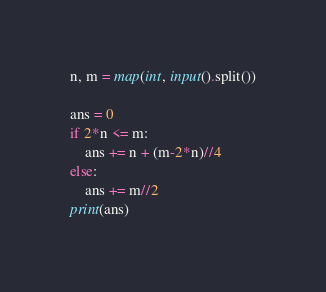Convert code to text. <code><loc_0><loc_0><loc_500><loc_500><_Python_>n, m = map(int, input().split())

ans = 0
if 2*n <= m:
    ans += n + (m-2*n)//4
else:
    ans += m//2
print(ans)
</code> 